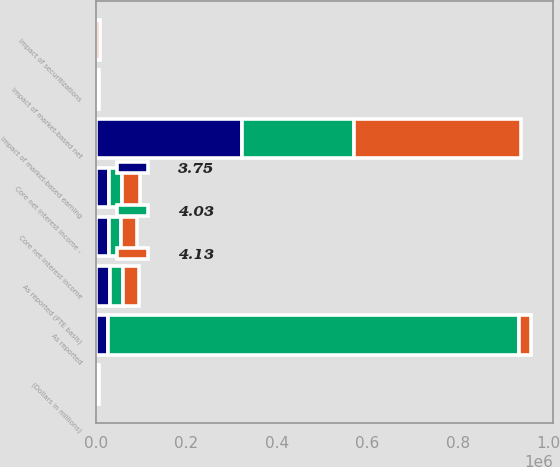<chart> <loc_0><loc_0><loc_500><loc_500><stacked_bar_chart><ecel><fcel>(Dollars in millions)<fcel>As reported (FTE basis)<fcel>Impact of market-based net<fcel>Core net interest income<fcel>Impact of securitizations<fcel>Core net interest income -<fcel>As reported<fcel>Impact of market-based earning<nl><fcel>4.13<fcel>2006<fcel>35815<fcel>1651<fcel>34164<fcel>7045<fcel>41209<fcel>27894<fcel>369164<nl><fcel>3.75<fcel>2005<fcel>31569<fcel>1938<fcel>29631<fcel>323<fcel>29954<fcel>27894<fcel>322236<nl><fcel>4.03<fcel>2004<fcel>28677<fcel>2606<fcel>26071<fcel>1040<fcel>27111<fcel>905273<fcel>246704<nl></chart> 